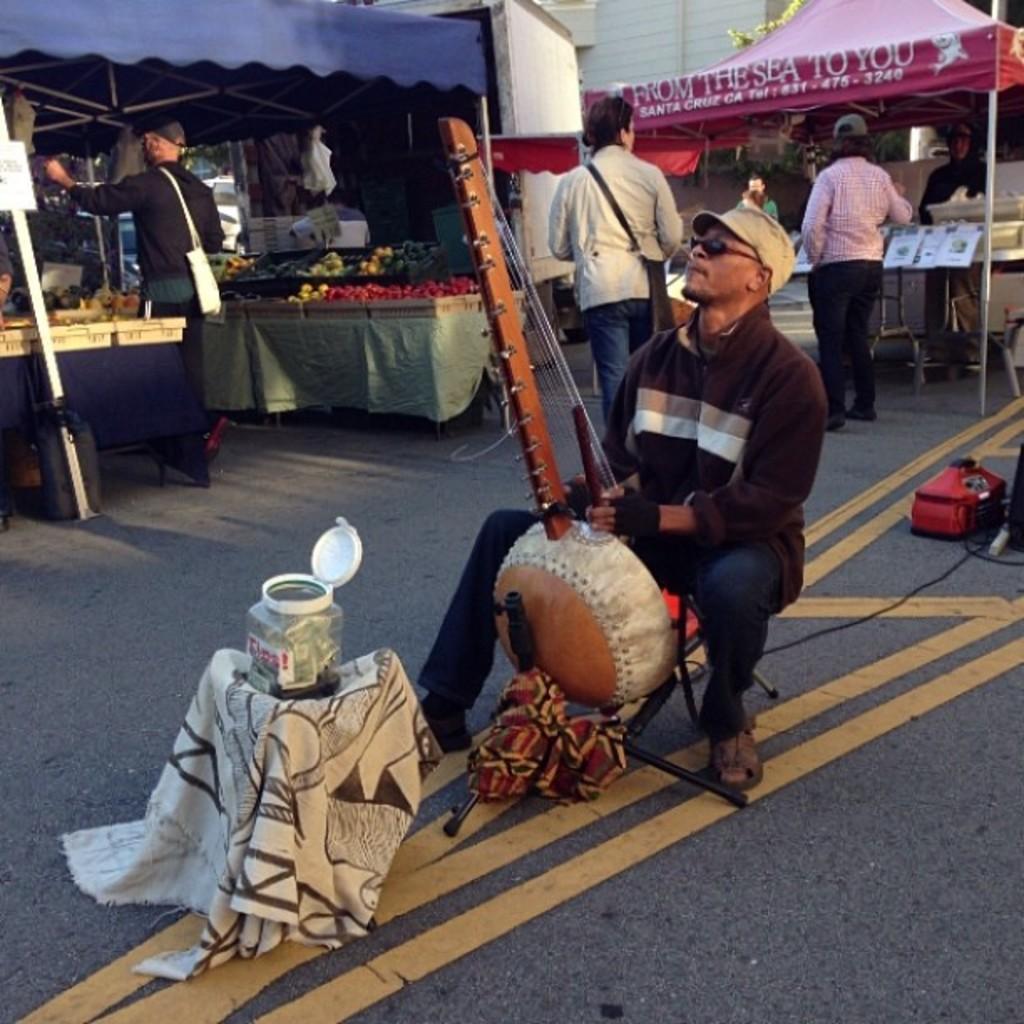Could you give a brief overview of what you see in this image? In this image, we can see persons wearing clothes. There are stalls at the top of the image. There is a person in the middle of the image playing a musical instrument. There is a jar and cloth in the bottom left of the image. 